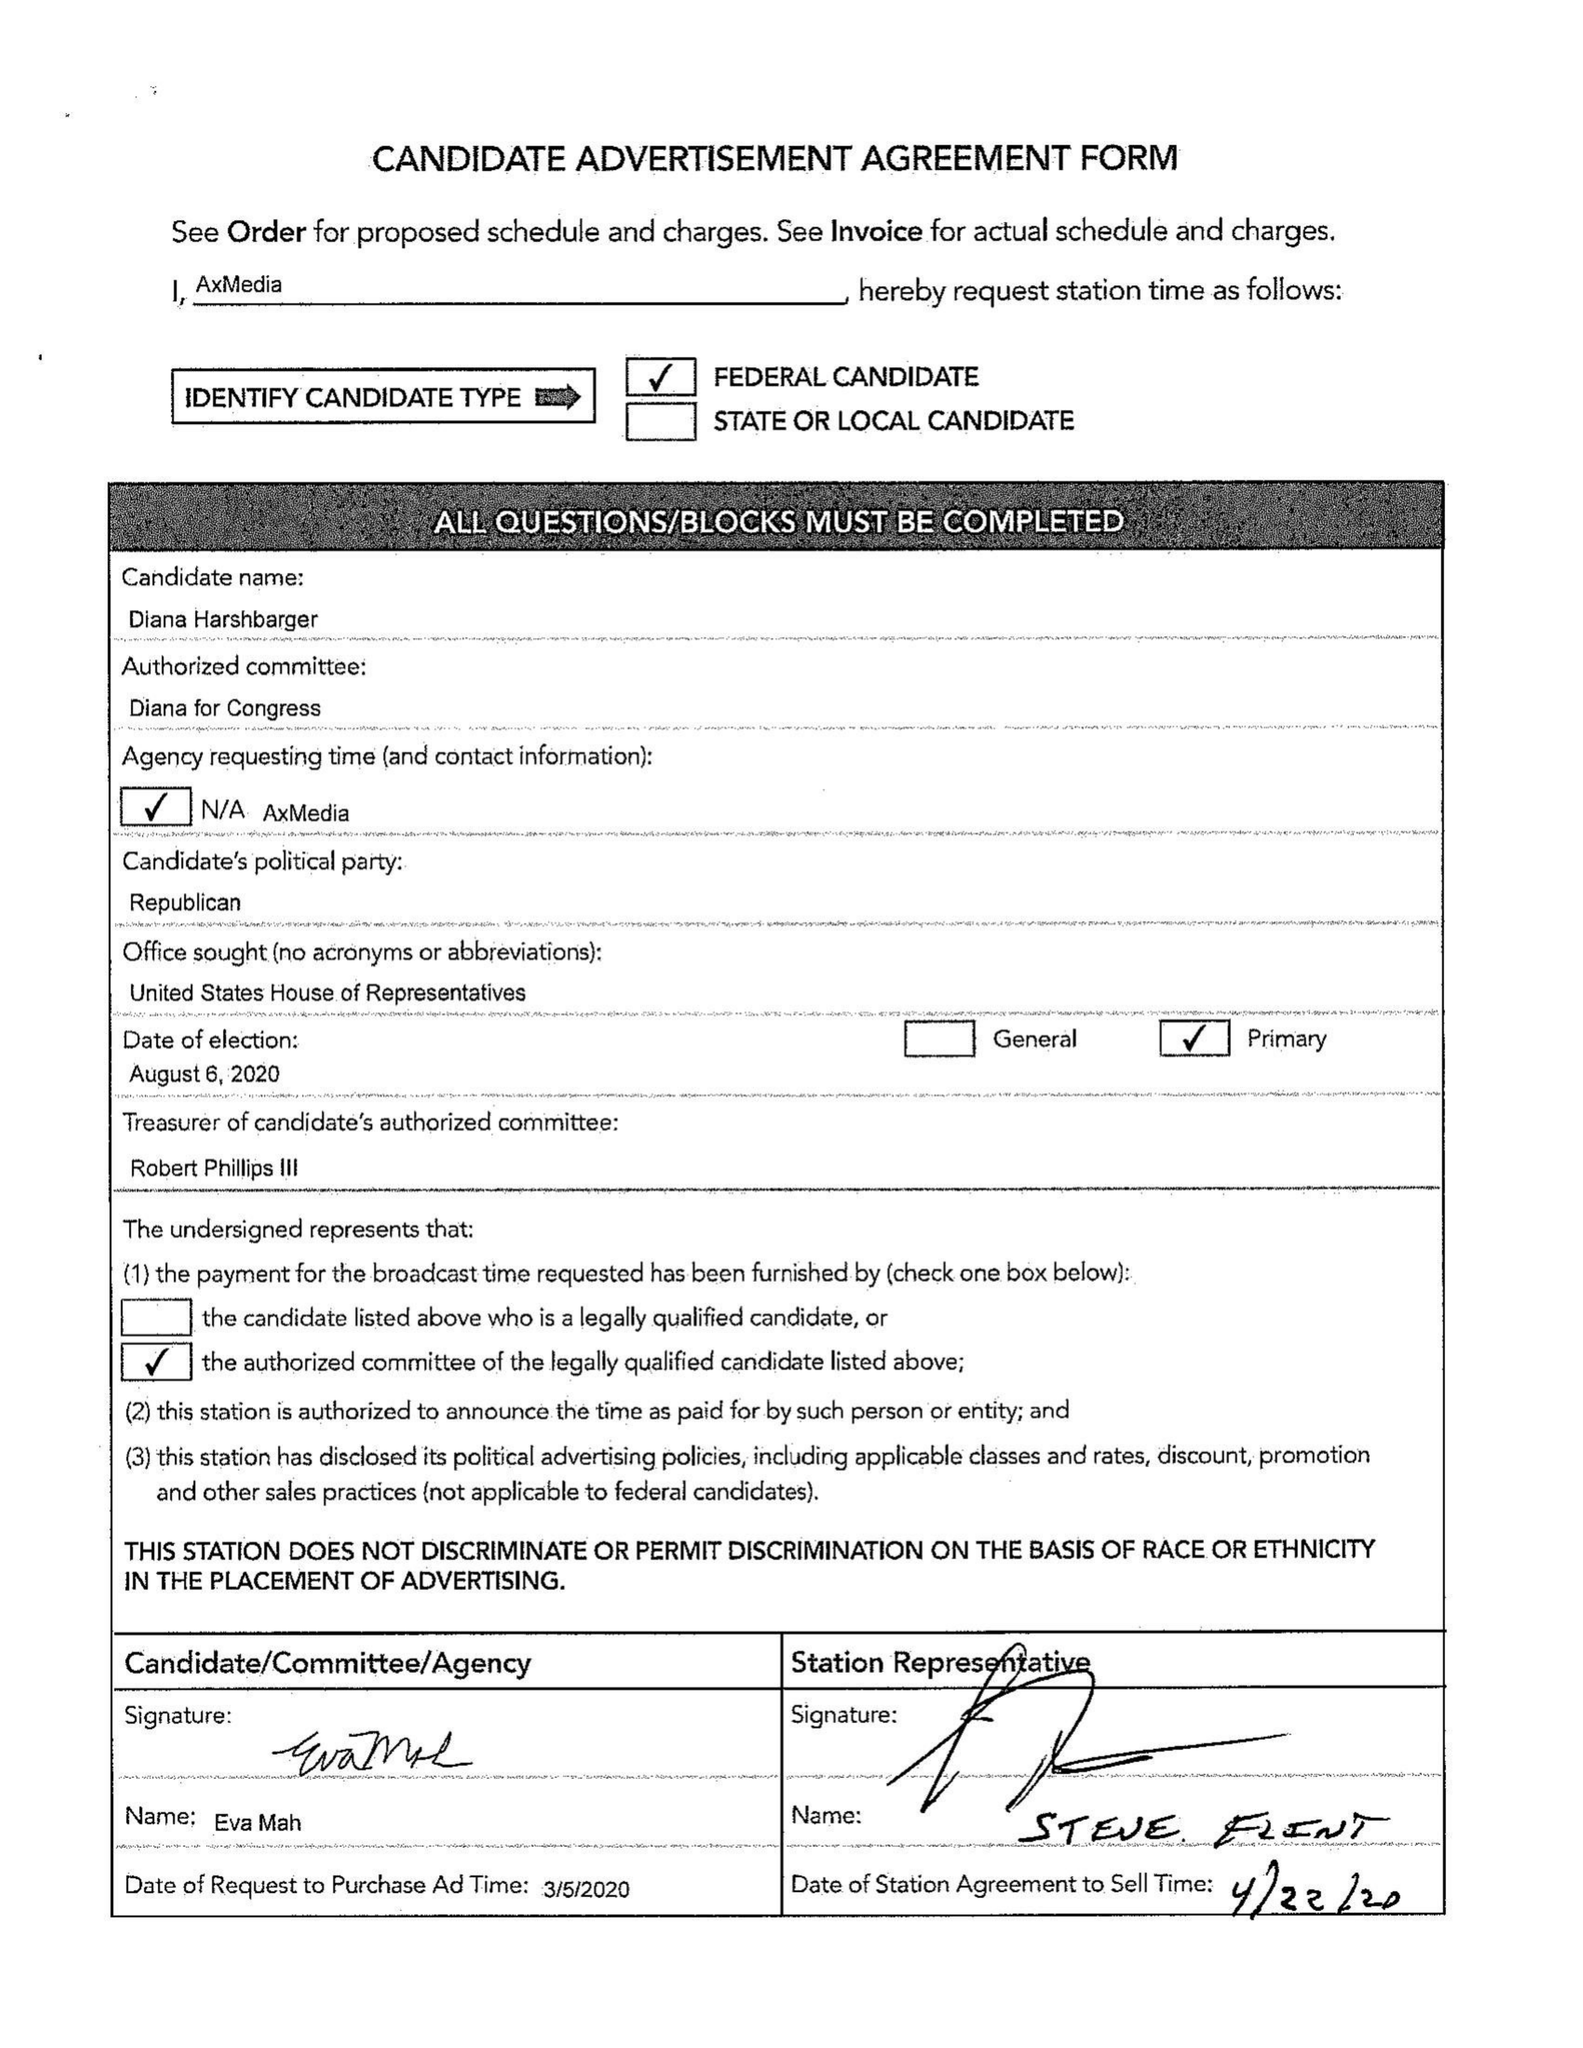What is the value for the advertiser?
Answer the question using a single word or phrase. DIANA HARSHBARGER FOR TN CD-1 